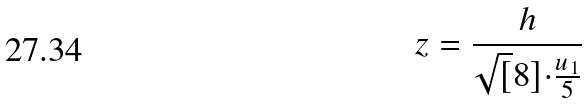Convert formula to latex. <formula><loc_0><loc_0><loc_500><loc_500>z = \frac { h } { \sqrt { [ } 8 ] { \cdot \frac { u _ { 1 } } { 5 } } }</formula> 